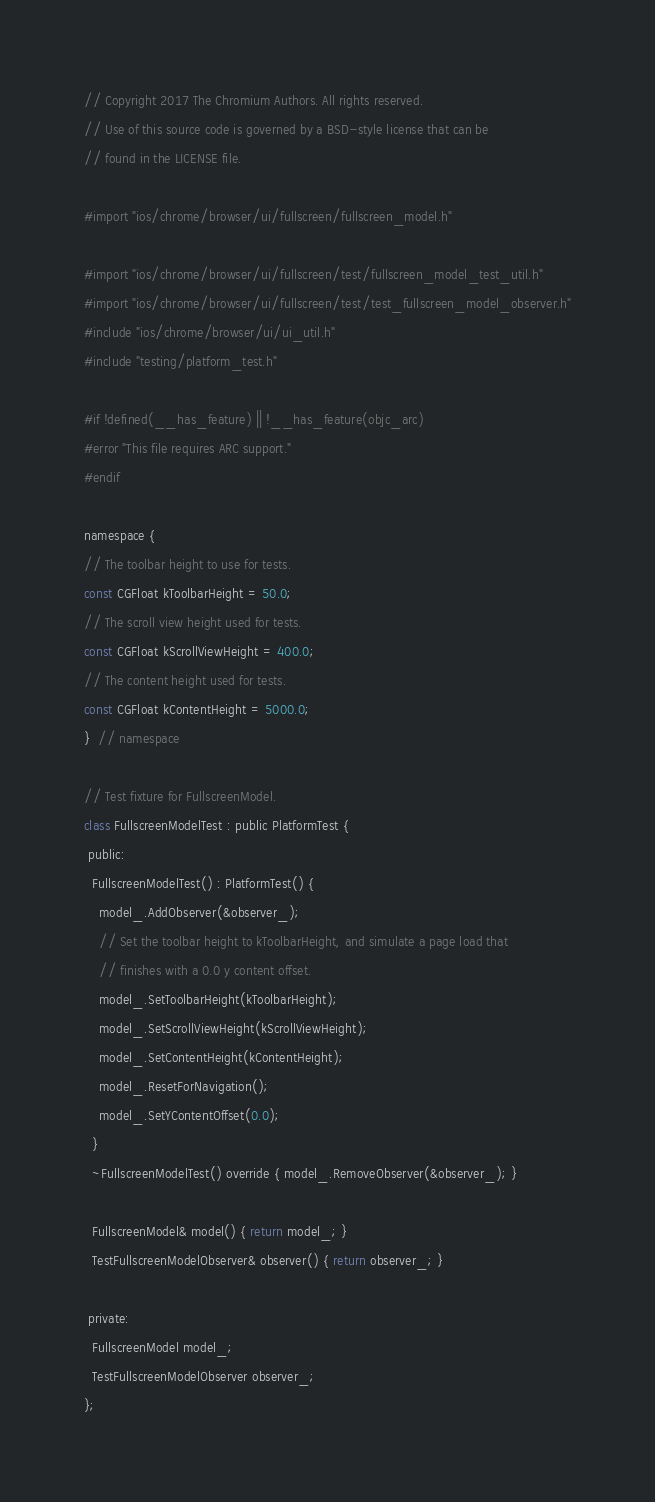<code> <loc_0><loc_0><loc_500><loc_500><_ObjectiveC_>// Copyright 2017 The Chromium Authors. All rights reserved.
// Use of this source code is governed by a BSD-style license that can be
// found in the LICENSE file.

#import "ios/chrome/browser/ui/fullscreen/fullscreen_model.h"

#import "ios/chrome/browser/ui/fullscreen/test/fullscreen_model_test_util.h"
#import "ios/chrome/browser/ui/fullscreen/test/test_fullscreen_model_observer.h"
#include "ios/chrome/browser/ui/ui_util.h"
#include "testing/platform_test.h"

#if !defined(__has_feature) || !__has_feature(objc_arc)
#error "This file requires ARC support."
#endif

namespace {
// The toolbar height to use for tests.
const CGFloat kToolbarHeight = 50.0;
// The scroll view height used for tests.
const CGFloat kScrollViewHeight = 400.0;
// The content height used for tests.
const CGFloat kContentHeight = 5000.0;
}  // namespace

// Test fixture for FullscreenModel.
class FullscreenModelTest : public PlatformTest {
 public:
  FullscreenModelTest() : PlatformTest() {
    model_.AddObserver(&observer_);
    // Set the toolbar height to kToolbarHeight, and simulate a page load that
    // finishes with a 0.0 y content offset.
    model_.SetToolbarHeight(kToolbarHeight);
    model_.SetScrollViewHeight(kScrollViewHeight);
    model_.SetContentHeight(kContentHeight);
    model_.ResetForNavigation();
    model_.SetYContentOffset(0.0);
  }
  ~FullscreenModelTest() override { model_.RemoveObserver(&observer_); }

  FullscreenModel& model() { return model_; }
  TestFullscreenModelObserver& observer() { return observer_; }

 private:
  FullscreenModel model_;
  TestFullscreenModelObserver observer_;
};
</code> 